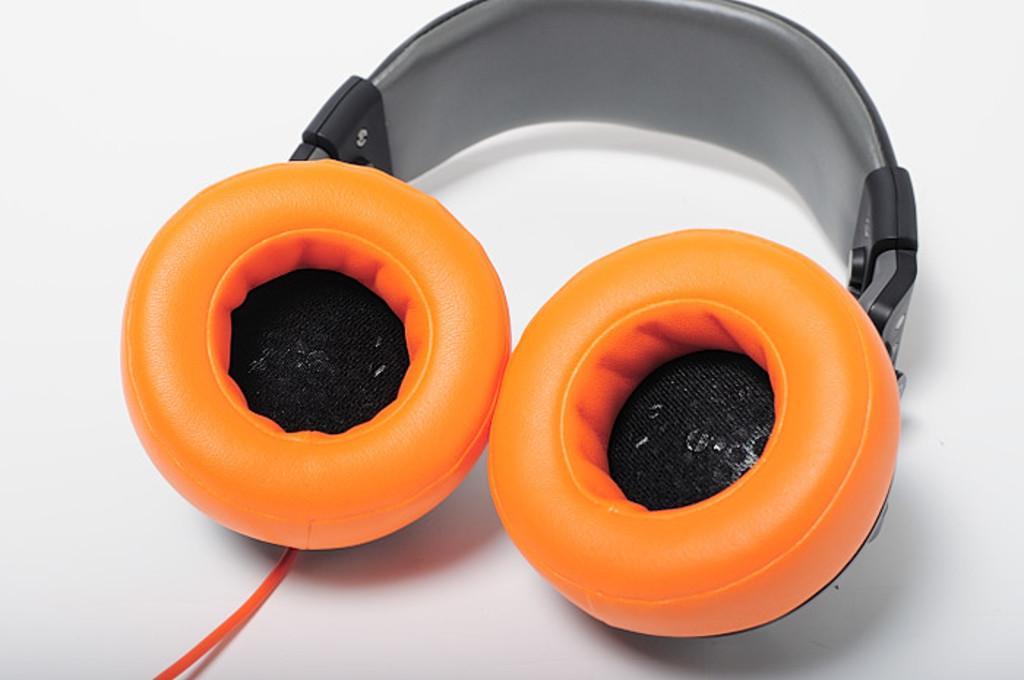How would you summarize this image in a sentence or two? In this image I can see a headphone in front which is of orange and black color and I can see a wire and it is on the white color surface. 